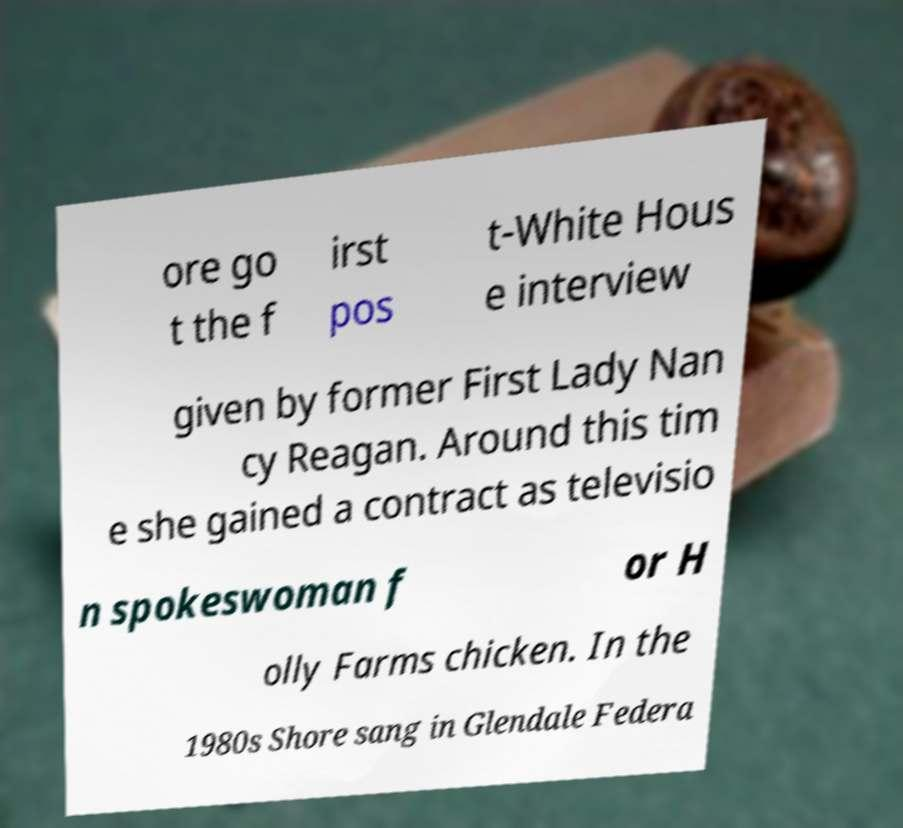There's text embedded in this image that I need extracted. Can you transcribe it verbatim? ore go t the f irst pos t-White Hous e interview given by former First Lady Nan cy Reagan. Around this tim e she gained a contract as televisio n spokeswoman f or H olly Farms chicken. In the 1980s Shore sang in Glendale Federa 